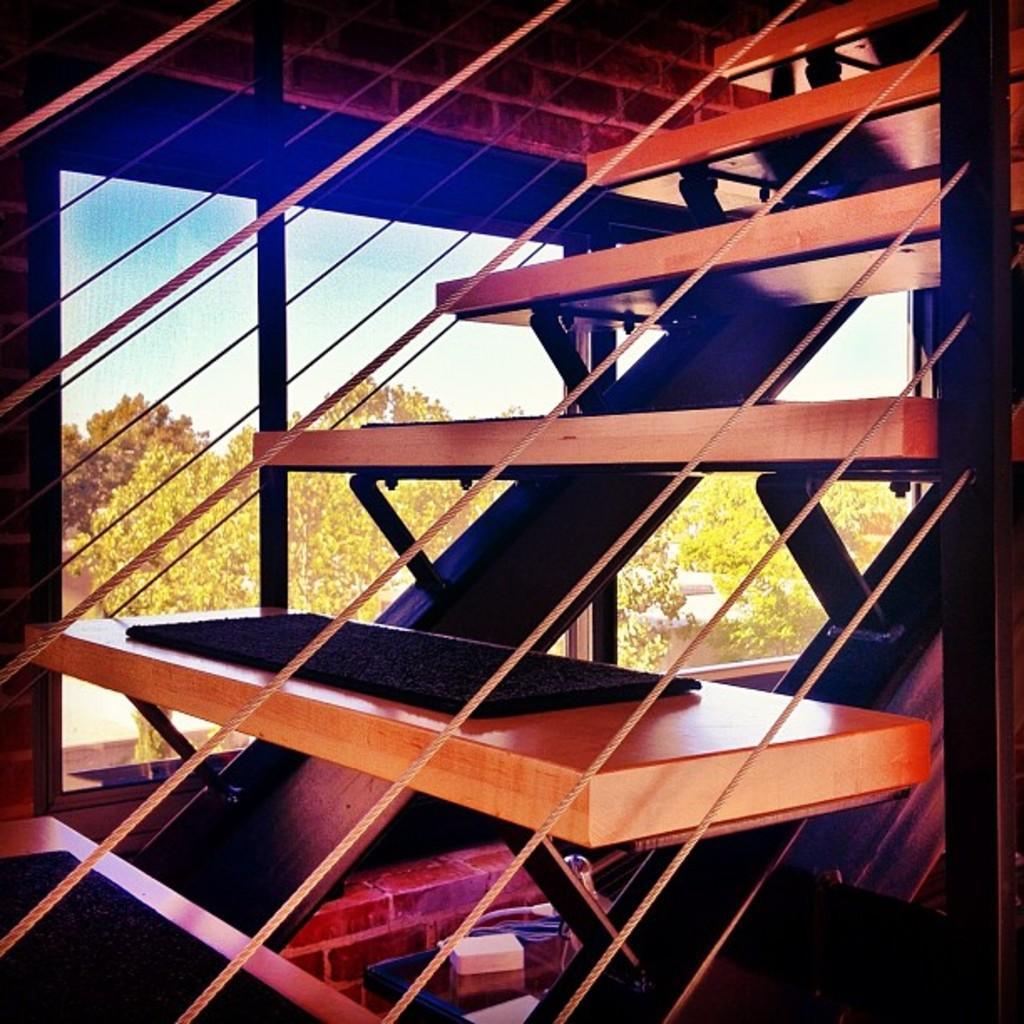Describe this image in one or two sentences. In this image we can see staircase, objects, windows and wall. Through the window glasses we can see trees and clouds in the sky. 